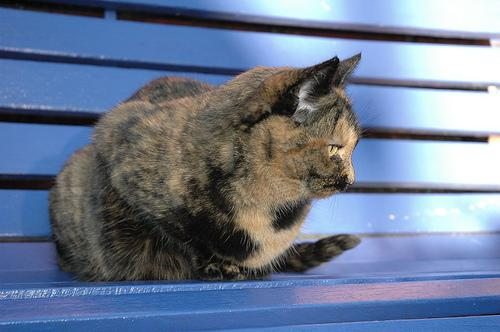Question: who is sitting on the bench?
Choices:
A. A couple.
B. A lawyer and client.
C. A clown.
D. The cat.
Answer with the letter. Answer: D Question: how many ears does the cat have?
Choices:
A. One.
B. Two.
C. Three.
D. Four.
Answer with the letter. Answer: B 